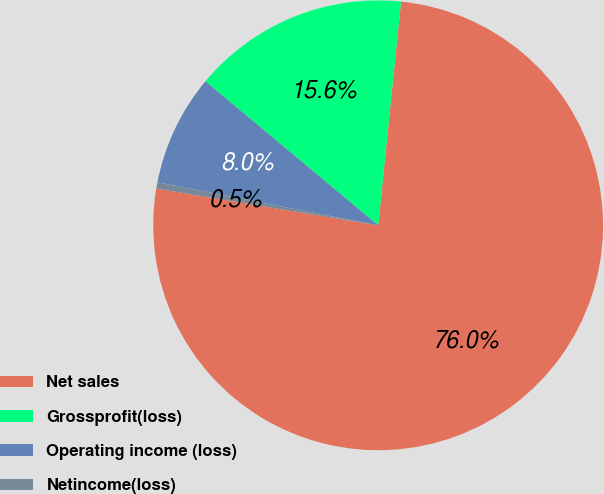Convert chart to OTSL. <chart><loc_0><loc_0><loc_500><loc_500><pie_chart><fcel>Net sales<fcel>Grossprofit(loss)<fcel>Operating income (loss)<fcel>Netincome(loss)<nl><fcel>75.99%<fcel>15.56%<fcel>8.0%<fcel>0.45%<nl></chart> 